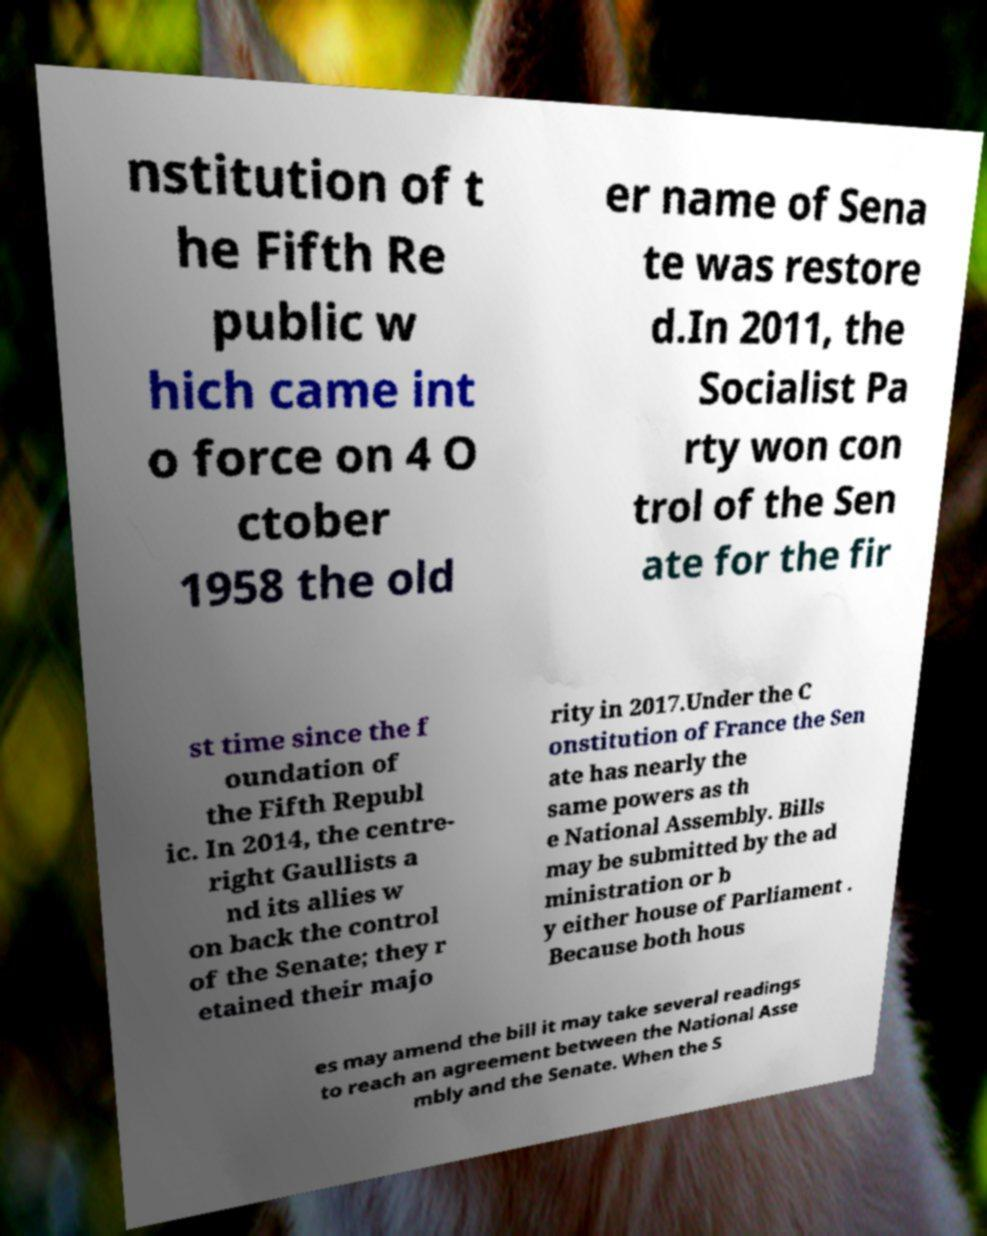Please read and relay the text visible in this image. What does it say? nstitution of t he Fifth Re public w hich came int o force on 4 O ctober 1958 the old er name of Sena te was restore d.In 2011, the Socialist Pa rty won con trol of the Sen ate for the fir st time since the f oundation of the Fifth Republ ic. In 2014, the centre- right Gaullists a nd its allies w on back the control of the Senate; they r etained their majo rity in 2017.Under the C onstitution of France the Sen ate has nearly the same powers as th e National Assembly. Bills may be submitted by the ad ministration or b y either house of Parliament . Because both hous es may amend the bill it may take several readings to reach an agreement between the National Asse mbly and the Senate. When the S 